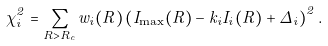<formula> <loc_0><loc_0><loc_500><loc_500>\chi ^ { 2 } _ { i } = \sum _ { R > R _ { c } } w _ { i } ( R ) \left ( I _ { \max } ( R ) - k _ { i } I _ { i } ( R ) + \Delta _ { i } \right ) ^ { 2 } .</formula> 